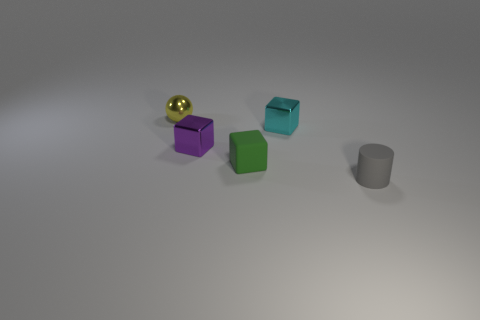Subtract all metallic blocks. How many blocks are left? 1 Subtract all cyan cubes. How many cubes are left? 2 Add 4 purple metallic cylinders. How many objects exist? 9 Subtract all cylinders. How many objects are left? 4 Subtract 1 gray cylinders. How many objects are left? 4 Subtract 1 cylinders. How many cylinders are left? 0 Subtract all cyan spheres. Subtract all brown cylinders. How many spheres are left? 1 Subtract all yellow blocks. How many cyan spheres are left? 0 Subtract all blocks. Subtract all tiny green blocks. How many objects are left? 1 Add 4 metal objects. How many metal objects are left? 7 